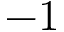Convert formula to latex. <formula><loc_0><loc_0><loc_500><loc_500>- 1</formula> 